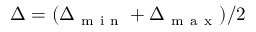Convert formula to latex. <formula><loc_0><loc_0><loc_500><loc_500>\Delta = ( \Delta _ { m i n } + \Delta _ { m a x } ) / 2</formula> 